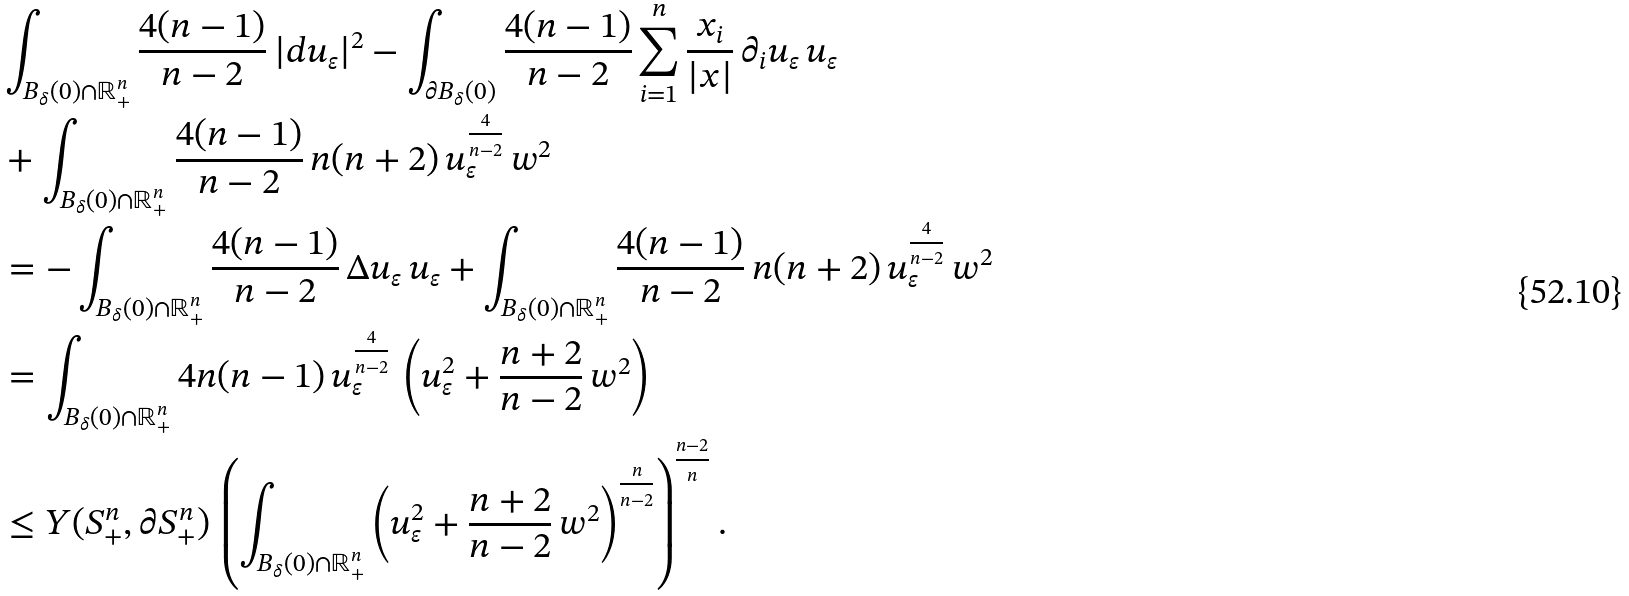Convert formula to latex. <formula><loc_0><loc_0><loc_500><loc_500>& \int _ { B _ { \delta } ( 0 ) \cap \mathbb { R } _ { + } ^ { n } } \frac { 4 ( n - 1 ) } { n - 2 } \, | d u _ { \varepsilon } | ^ { 2 } - \int _ { \partial B _ { \delta } ( 0 ) } \frac { 4 ( n - 1 ) } { n - 2 } \sum _ { i = 1 } ^ { n } \frac { x _ { i } } { | x | } \, \partial _ { i } u _ { \varepsilon } \, u _ { \varepsilon } \\ & + \int _ { B _ { \delta } ( 0 ) \cap \mathbb { R } _ { + } ^ { n } } \frac { 4 ( n - 1 ) } { n - 2 } \, n ( n + 2 ) \, u _ { \varepsilon } ^ { \frac { 4 } { n - 2 } } \, w ^ { 2 } \\ & = - \int _ { B _ { \delta } ( 0 ) \cap \mathbb { R } _ { + } ^ { n } } \frac { 4 ( n - 1 ) } { n - 2 } \, \Delta u _ { \varepsilon } \, u _ { \varepsilon } + \int _ { B _ { \delta } ( 0 ) \cap \mathbb { R } _ { + } ^ { n } } \frac { 4 ( n - 1 ) } { n - 2 } \, n ( n + 2 ) \, u _ { \varepsilon } ^ { \frac { 4 } { n - 2 } } \, w ^ { 2 } \\ & = \int _ { B _ { \delta } ( 0 ) \cap \mathbb { R } _ { + } ^ { n } } 4 n ( n - 1 ) \, u _ { \varepsilon } ^ { \frac { 4 } { n - 2 } } \, \left ( u _ { \varepsilon } ^ { 2 } + \frac { n + 2 } { n - 2 } \, w ^ { 2 } \right ) \\ & \leq Y ( S _ { + } ^ { n } , \partial S _ { + } ^ { n } ) \, \left ( \int _ { B _ { \delta } ( 0 ) \cap \mathbb { R } _ { + } ^ { n } } \left ( u _ { \varepsilon } ^ { 2 } + \frac { n + 2 } { n - 2 } \, w ^ { 2 } \right ) ^ { \frac { n } { n - 2 } } \right ) ^ { \frac { n - 2 } { n } } .</formula> 